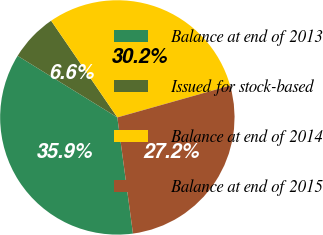Convert chart to OTSL. <chart><loc_0><loc_0><loc_500><loc_500><pie_chart><fcel>Balance at end of 2013<fcel>Issued for stock-based<fcel>Balance at end of 2014<fcel>Balance at end of 2015<nl><fcel>35.94%<fcel>6.64%<fcel>30.18%<fcel>27.25%<nl></chart> 